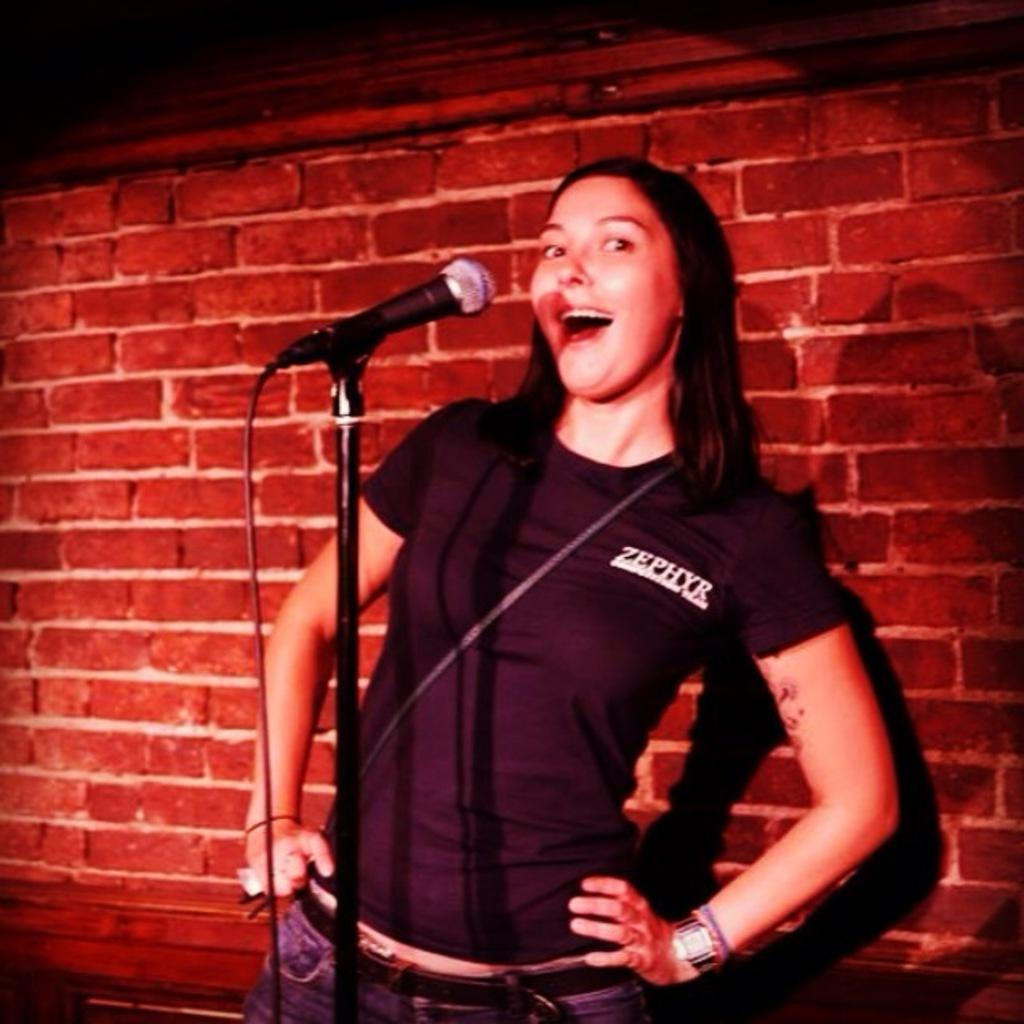Who is the main subject in the image? There is a girl in the image. Where is the girl positioned in the image? The girl is standing in the center of the image. What object is in front of the girl? There is a microphone in front of the girl. What can be seen behind the girl in the image? There is a brick wall in the background of the image. What type of punishment is the girl receiving in the image? There is no indication of punishment in the image; the girl is simply standing with a microphone in front of her. 